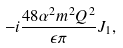Convert formula to latex. <formula><loc_0><loc_0><loc_500><loc_500>- i \frac { 4 8 \alpha ^ { 2 } m ^ { 2 } Q ^ { 2 } } { \epsilon \pi } J _ { 1 } ,</formula> 